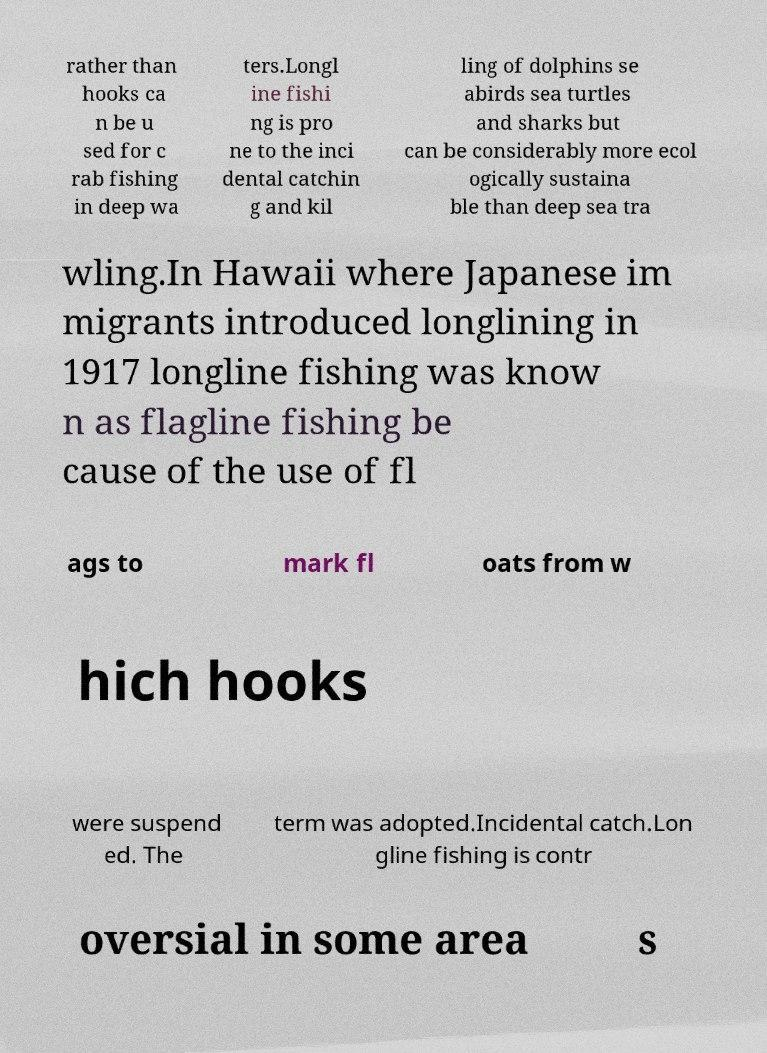Can you read and provide the text displayed in the image?This photo seems to have some interesting text. Can you extract and type it out for me? rather than hooks ca n be u sed for c rab fishing in deep wa ters.Longl ine fishi ng is pro ne to the inci dental catchin g and kil ling of dolphins se abirds sea turtles and sharks but can be considerably more ecol ogically sustaina ble than deep sea tra wling.In Hawaii where Japanese im migrants introduced longlining in 1917 longline fishing was know n as flagline fishing be cause of the use of fl ags to mark fl oats from w hich hooks were suspend ed. The term was adopted.Incidental catch.Lon gline fishing is contr oversial in some area s 